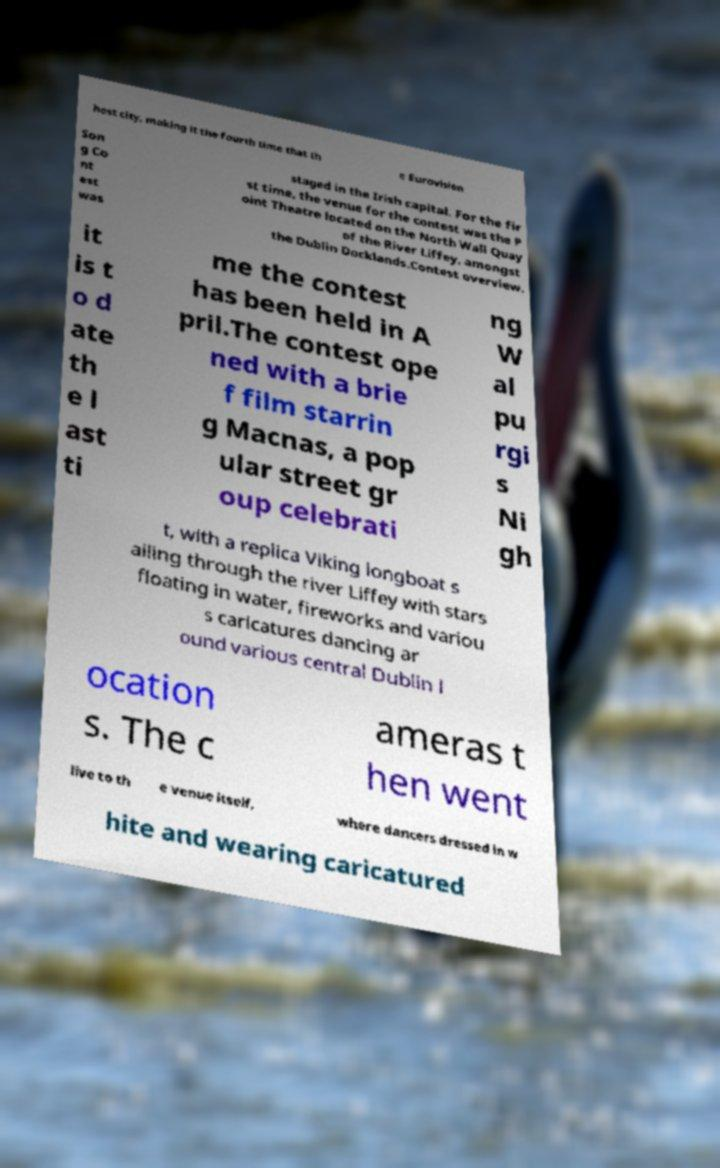I need the written content from this picture converted into text. Can you do that? host city, making it the fourth time that th e Eurovision Son g Co nt est was staged in the Irish capital. For the fir st time, the venue for the contest was the P oint Theatre located on the North Wall Quay of the River Liffey, amongst the Dublin Docklands.Contest overview. it is t o d ate th e l ast ti me the contest has been held in A pril.The contest ope ned with a brie f film starrin g Macnas, a pop ular street gr oup celebrati ng W al pu rgi s Ni gh t, with a replica Viking longboat s ailing through the river Liffey with stars floating in water, fireworks and variou s caricatures dancing ar ound various central Dublin l ocation s. The c ameras t hen went live to th e venue itself, where dancers dressed in w hite and wearing caricatured 